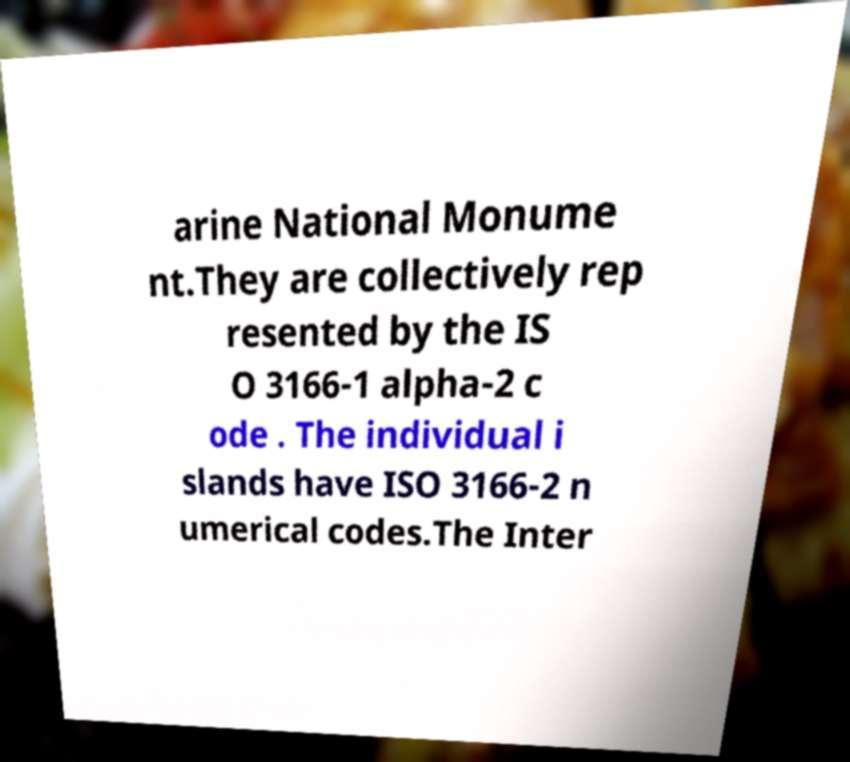Please identify and transcribe the text found in this image. arine National Monume nt.They are collectively rep resented by the IS O 3166-1 alpha-2 c ode . The individual i slands have ISO 3166-2 n umerical codes.The Inter 